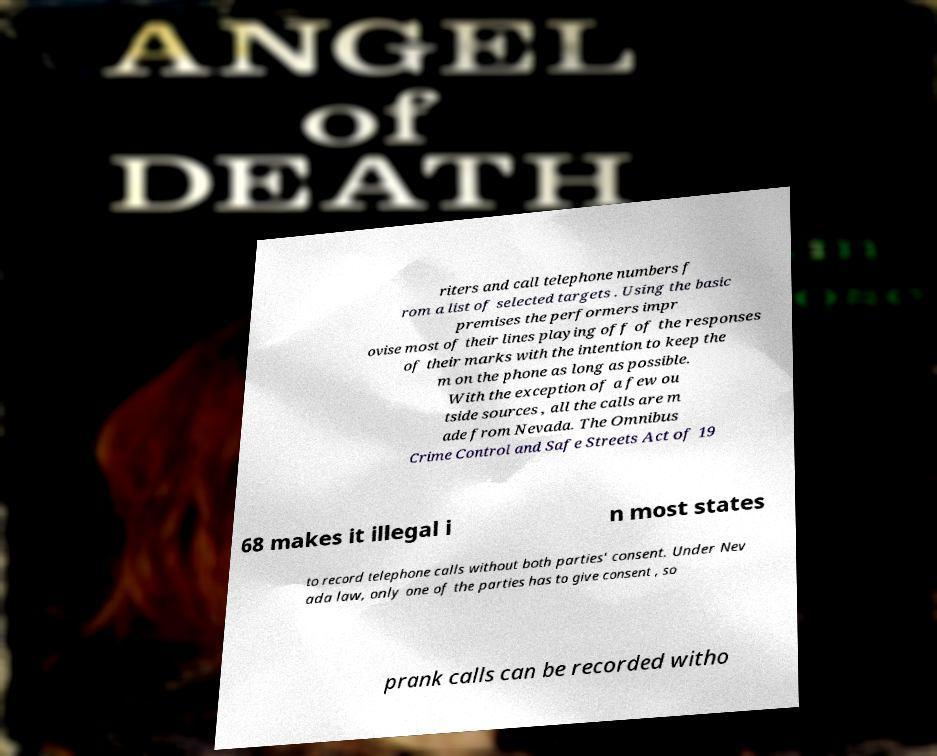For documentation purposes, I need the text within this image transcribed. Could you provide that? riters and call telephone numbers f rom a list of selected targets . Using the basic premises the performers impr ovise most of their lines playing off of the responses of their marks with the intention to keep the m on the phone as long as possible. With the exception of a few ou tside sources , all the calls are m ade from Nevada. The Omnibus Crime Control and Safe Streets Act of 19 68 makes it illegal i n most states to record telephone calls without both parties' consent. Under Nev ada law, only one of the parties has to give consent , so prank calls can be recorded witho 